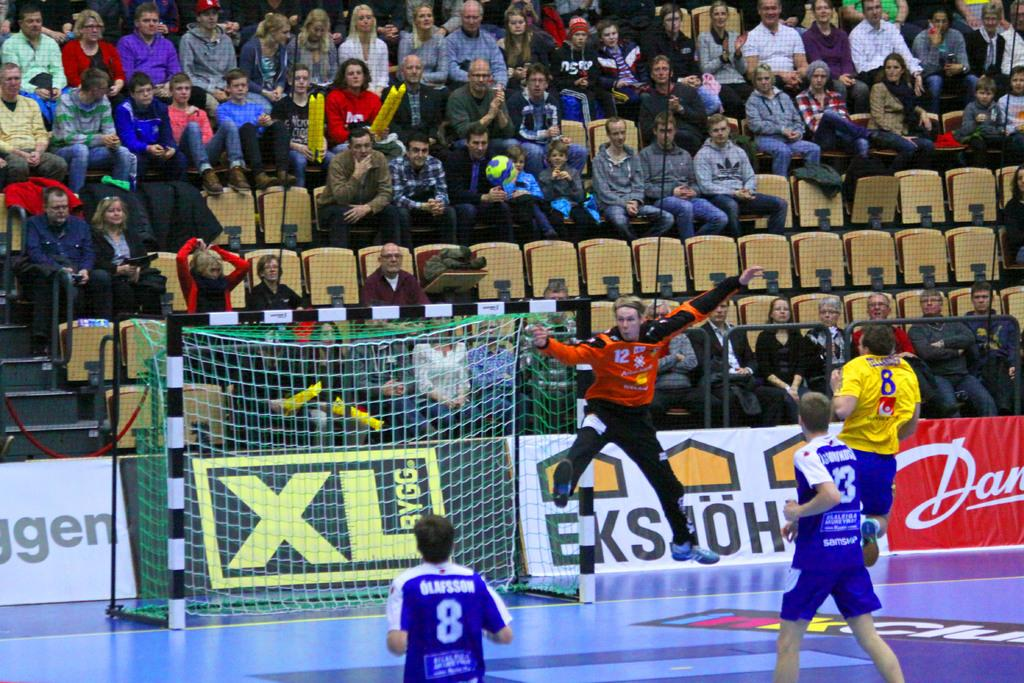Provide a one-sentence caption for the provided image. XL Bygg sign on a black and gold poster board. 